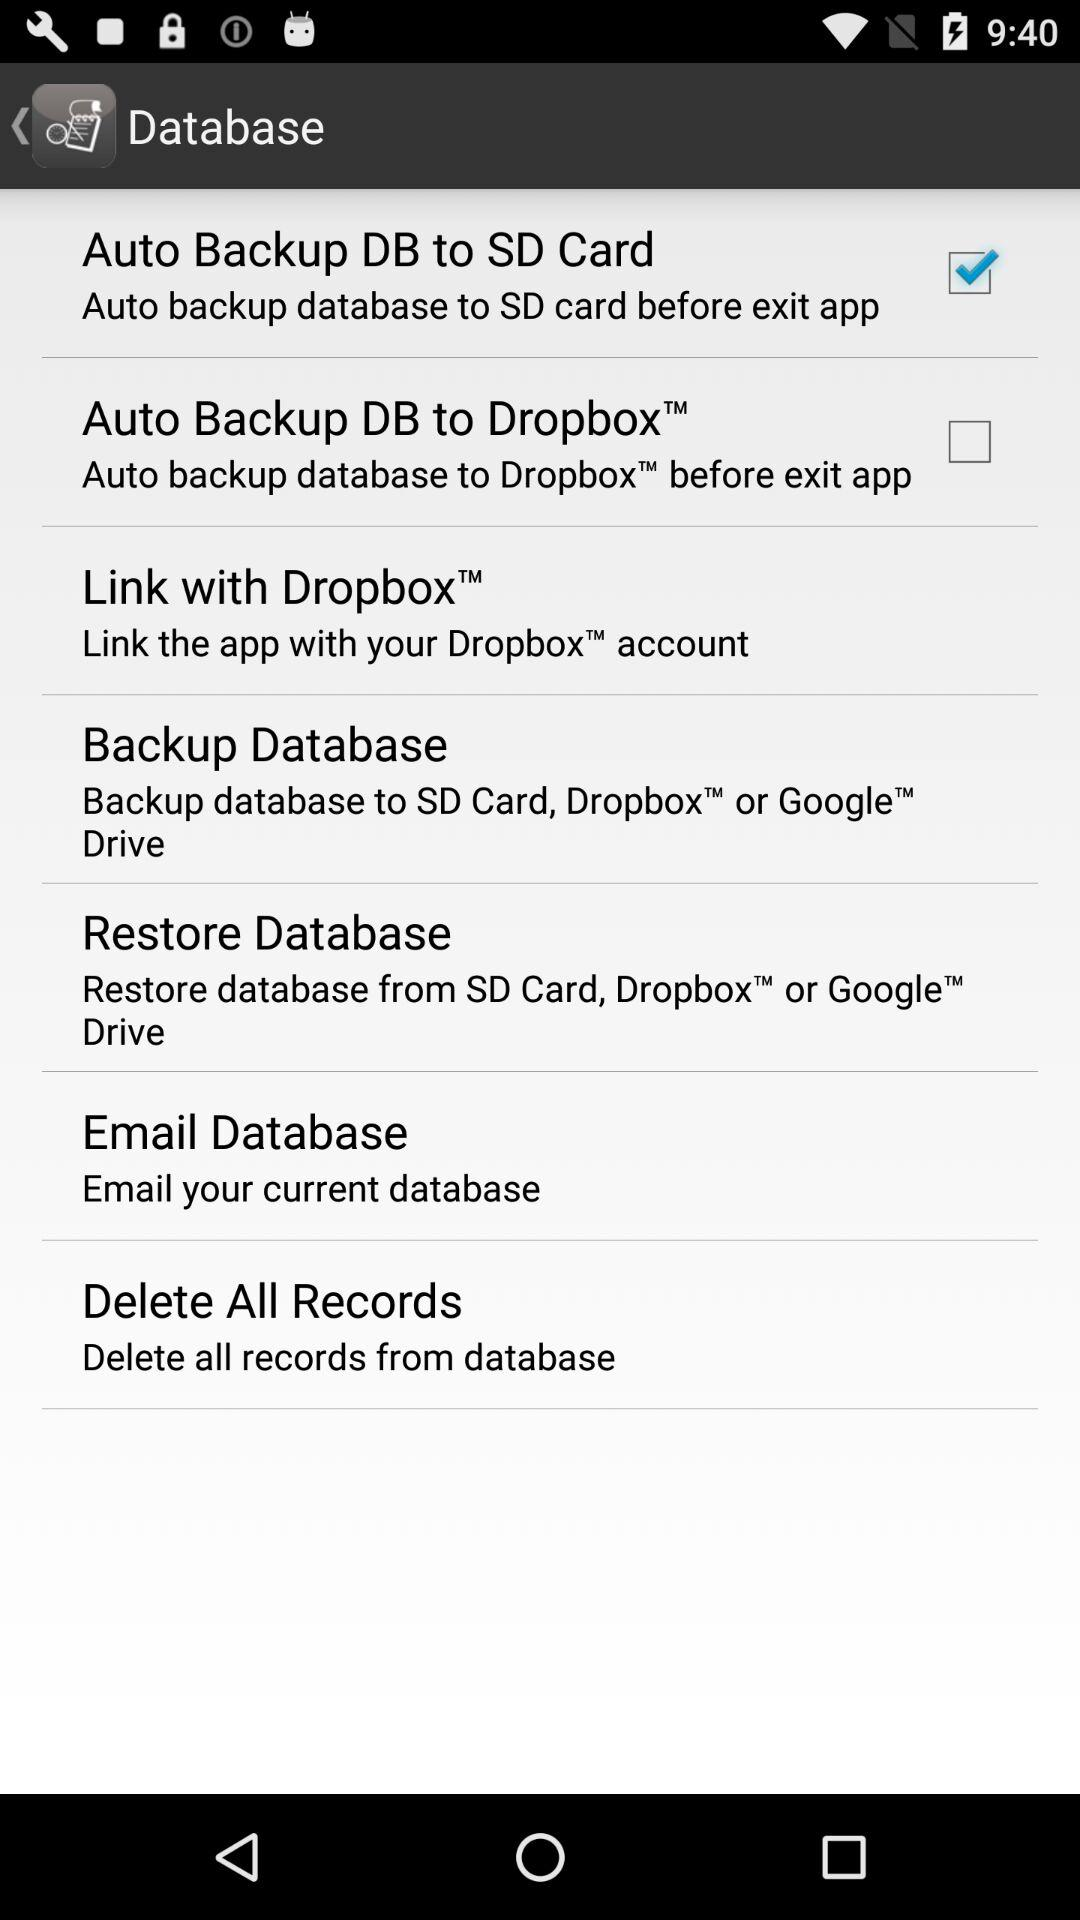How many of the items in the settings menu have a checkbox?
Answer the question using a single word or phrase. 2 